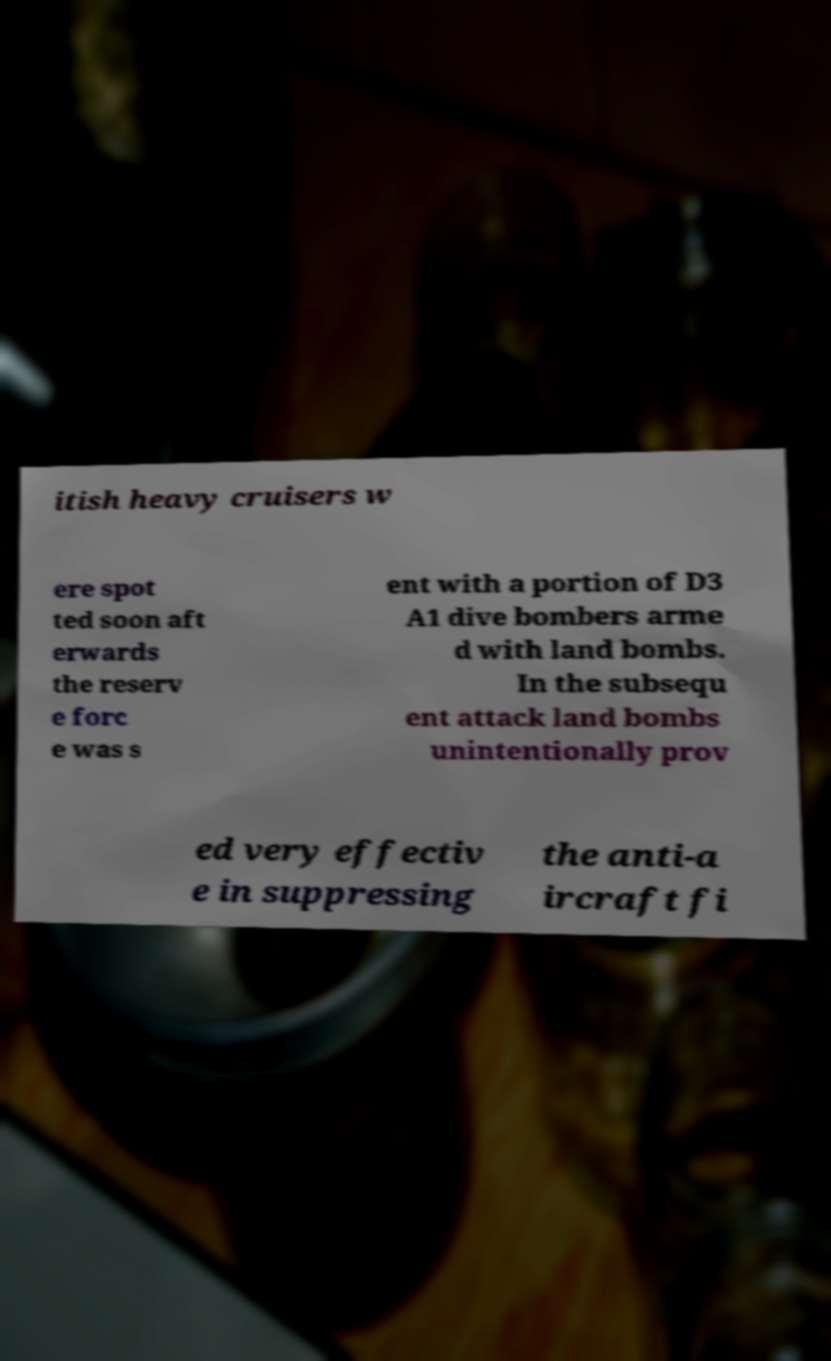Please identify and transcribe the text found in this image. itish heavy cruisers w ere spot ted soon aft erwards the reserv e forc e was s ent with a portion of D3 A1 dive bombers arme d with land bombs. In the subsequ ent attack land bombs unintentionally prov ed very effectiv e in suppressing the anti-a ircraft fi 